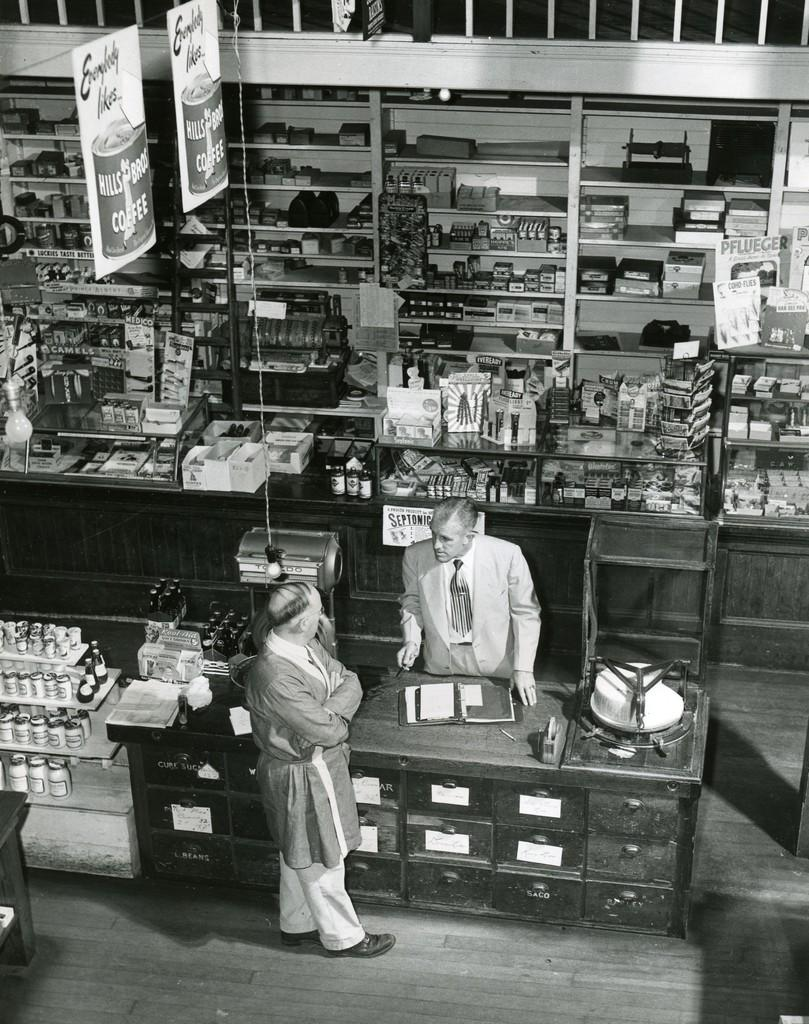Provide a one-sentence caption for the provided image. Black and white photo of a man talking to a person with a sign "Septonic" behind him. 